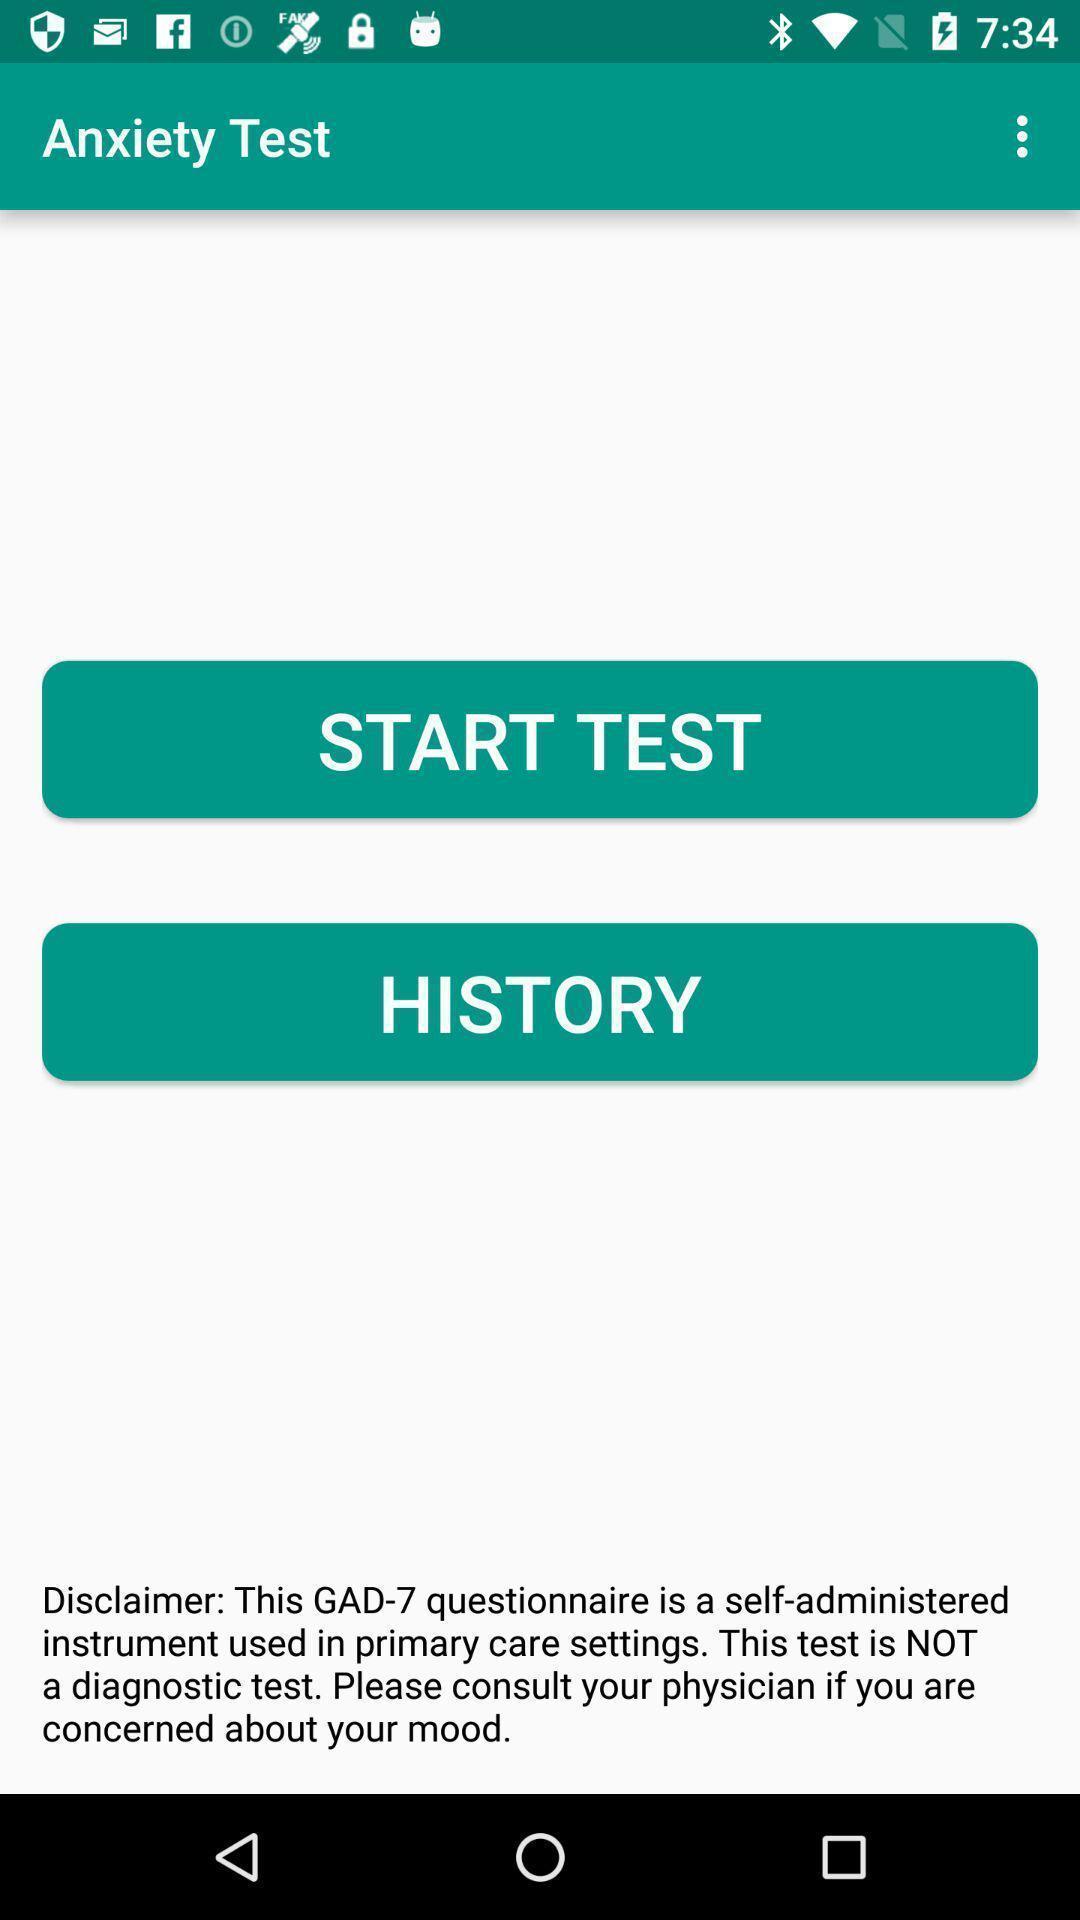Provide a textual representation of this image. Starting page for the health care app. 